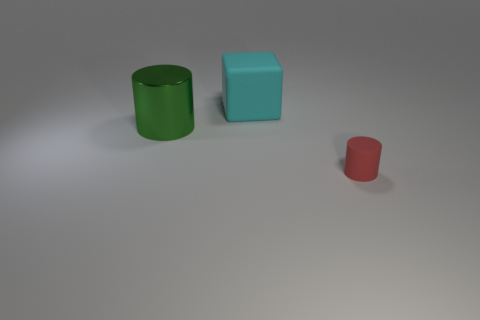How many other objects are there of the same material as the cyan block?
Ensure brevity in your answer.  1. Is the shape of the matte object that is behind the small matte object the same as the rubber thing that is on the right side of the cyan cube?
Your answer should be compact. No. What is the color of the object in front of the large object that is left of the big thing that is on the right side of the shiny cylinder?
Offer a very short reply. Red. Are there fewer cyan matte cubes than things?
Your answer should be compact. Yes. What color is the object that is both in front of the cyan cube and behind the matte cylinder?
Ensure brevity in your answer.  Green. There is a small red object that is the same shape as the green object; what material is it?
Offer a terse response. Rubber. Is there anything else that has the same size as the red thing?
Provide a succinct answer. No. Are there more cyan matte things than matte objects?
Ensure brevity in your answer.  No. What size is the object that is behind the red thing and in front of the block?
Provide a succinct answer. Large. There is a tiny red thing; what shape is it?
Your response must be concise. Cylinder. 